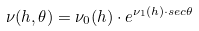<formula> <loc_0><loc_0><loc_500><loc_500>\nu ( h , \theta ) = \nu _ { 0 } ( h ) \cdot e ^ { \nu _ { 1 } ( h ) \cdot s e c \theta }</formula> 